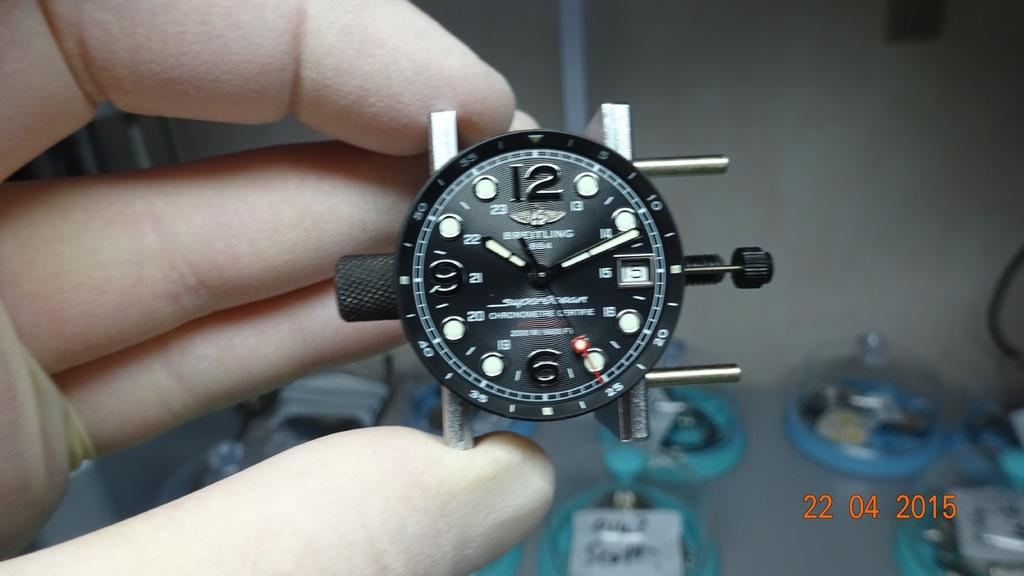Provide a one-sentence caption for the provided image. A black and white watch showing the time as 10:10. 